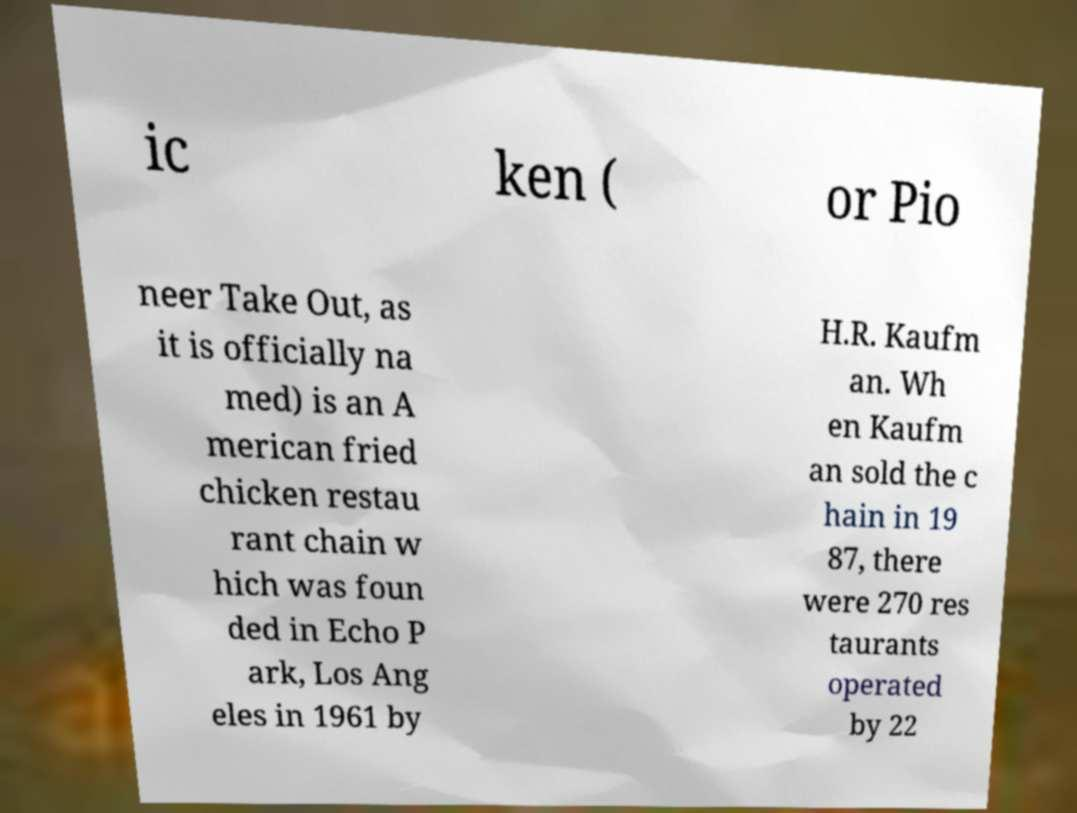I need the written content from this picture converted into text. Can you do that? ic ken ( or Pio neer Take Out, as it is officially na med) is an A merican fried chicken restau rant chain w hich was foun ded in Echo P ark, Los Ang eles in 1961 by H.R. Kaufm an. Wh en Kaufm an sold the c hain in 19 87, there were 270 res taurants operated by 22 